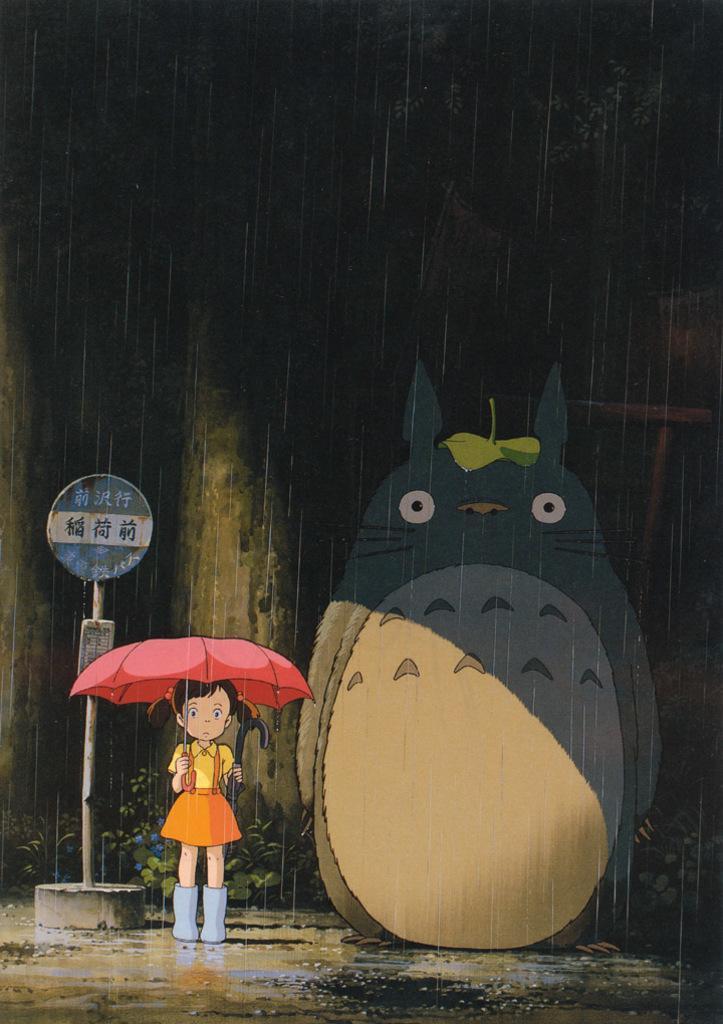Describe this image in one or two sentences. In this image I can see a girl is holding an umbrella in hand on the road, pole and a toy. In the background I can see a dark color and rain. This image looks like a animated picture. 